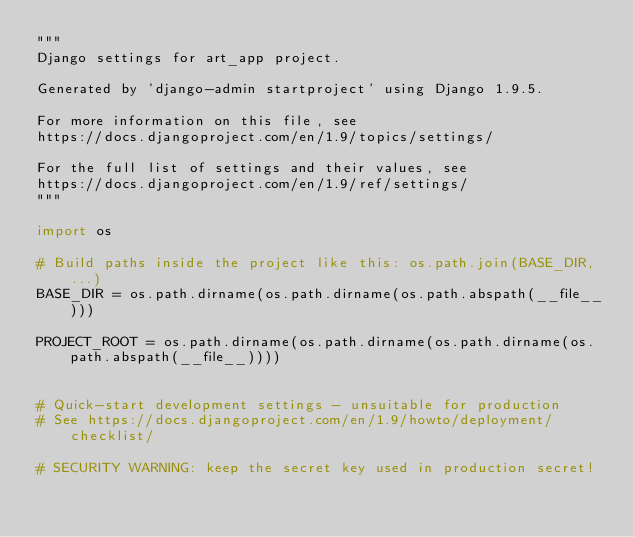Convert code to text. <code><loc_0><loc_0><loc_500><loc_500><_Python_>"""
Django settings for art_app project.

Generated by 'django-admin startproject' using Django 1.9.5.

For more information on this file, see
https://docs.djangoproject.com/en/1.9/topics/settings/

For the full list of settings and their values, see
https://docs.djangoproject.com/en/1.9/ref/settings/
"""

import os

# Build paths inside the project like this: os.path.join(BASE_DIR, ...)
BASE_DIR = os.path.dirname(os.path.dirname(os.path.abspath(__file__)))

PROJECT_ROOT = os.path.dirname(os.path.dirname(os.path.dirname(os.path.abspath(__file__))))


# Quick-start development settings - unsuitable for production
# See https://docs.djangoproject.com/en/1.9/howto/deployment/checklist/

# SECURITY WARNING: keep the secret key used in production secret!</code> 